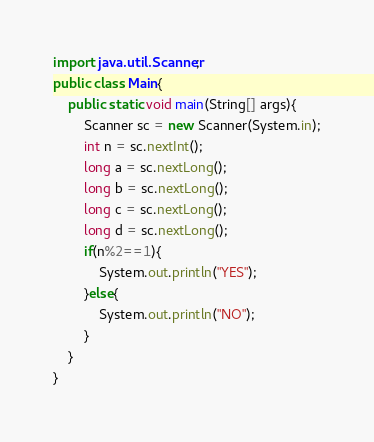Convert code to text. <code><loc_0><loc_0><loc_500><loc_500><_Java_>import java.util.Scanner;
public class Main{
	public static void main(String[] args){
		Scanner sc = new Scanner(System.in);
		int n = sc.nextInt();
		long a = sc.nextLong();
		long b = sc.nextLong();
		long c = sc.nextLong();
		long d = sc.nextLong();
		if(n%2==1){
			System.out.println("YES");
		}else{
			System.out.println("NO");
		}
	}
}</code> 